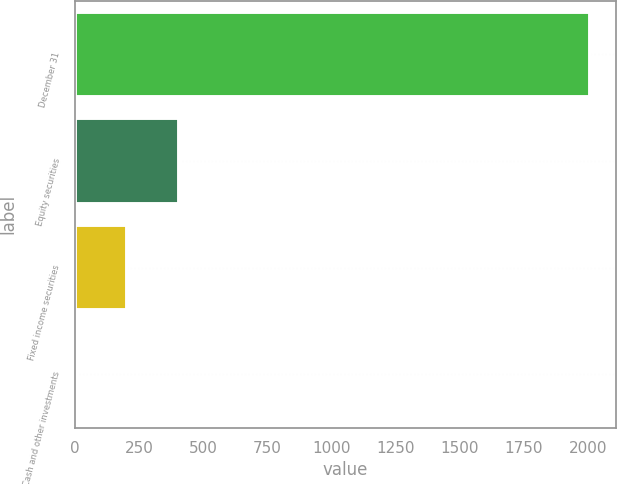Convert chart to OTSL. <chart><loc_0><loc_0><loc_500><loc_500><bar_chart><fcel>December 31<fcel>Equity securities<fcel>Fixed income securities<fcel>Cash and other investments<nl><fcel>2009<fcel>404.2<fcel>203.6<fcel>3<nl></chart> 